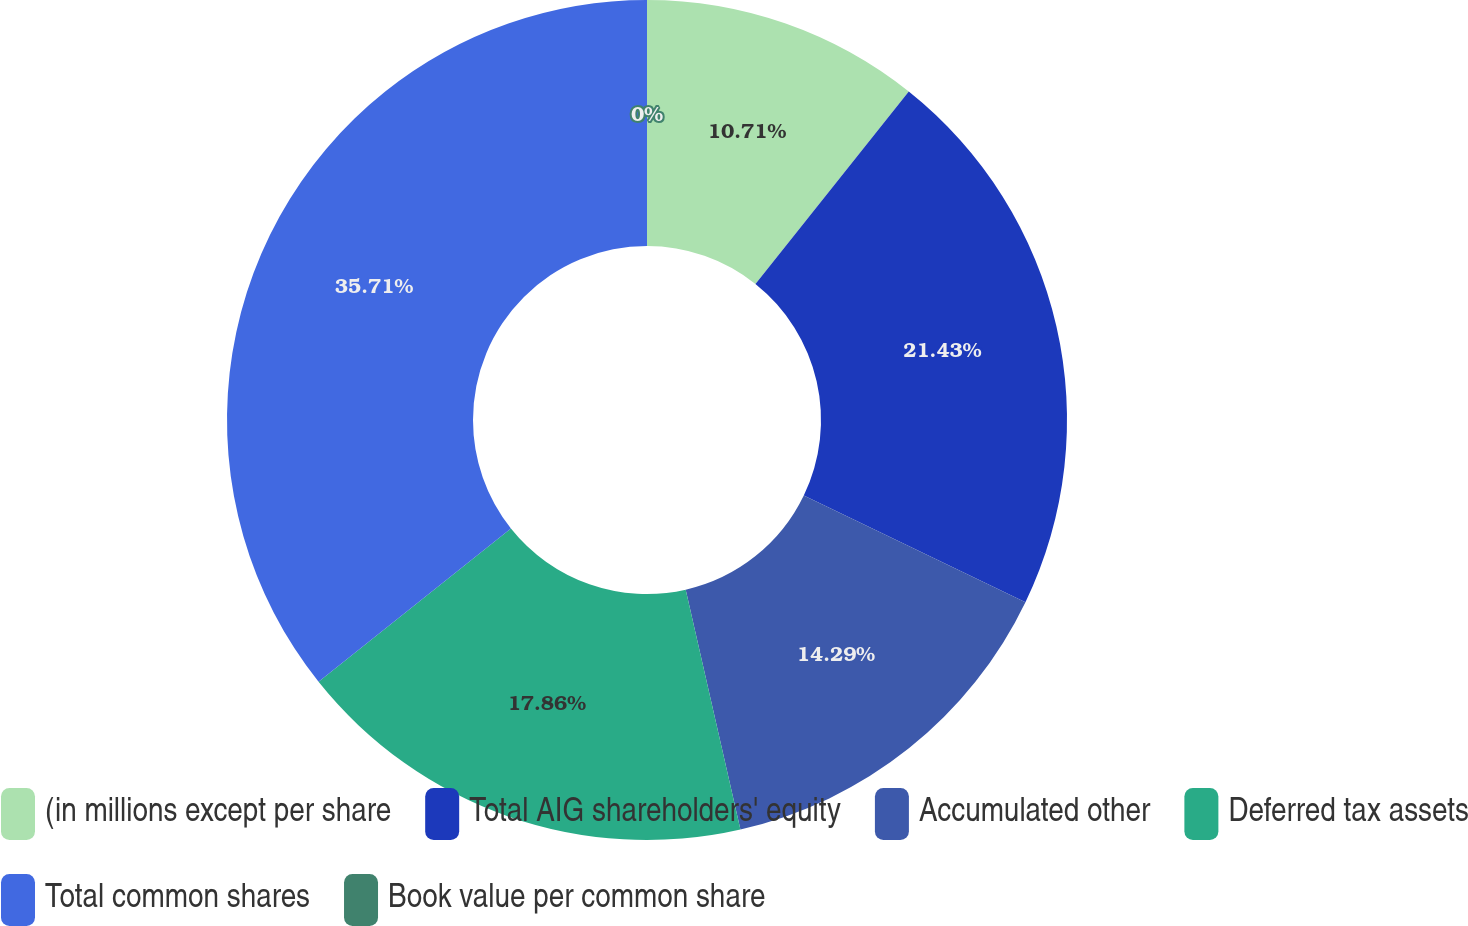Convert chart to OTSL. <chart><loc_0><loc_0><loc_500><loc_500><pie_chart><fcel>(in millions except per share<fcel>Total AIG shareholders' equity<fcel>Accumulated other<fcel>Deferred tax assets<fcel>Total common shares<fcel>Book value per common share<nl><fcel>10.71%<fcel>21.43%<fcel>14.29%<fcel>17.86%<fcel>35.71%<fcel>0.0%<nl></chart> 